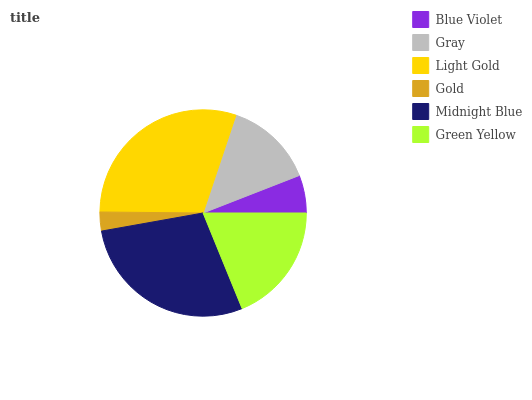Is Gold the minimum?
Answer yes or no. Yes. Is Light Gold the maximum?
Answer yes or no. Yes. Is Gray the minimum?
Answer yes or no. No. Is Gray the maximum?
Answer yes or no. No. Is Gray greater than Blue Violet?
Answer yes or no. Yes. Is Blue Violet less than Gray?
Answer yes or no. Yes. Is Blue Violet greater than Gray?
Answer yes or no. No. Is Gray less than Blue Violet?
Answer yes or no. No. Is Green Yellow the high median?
Answer yes or no. Yes. Is Gray the low median?
Answer yes or no. Yes. Is Gold the high median?
Answer yes or no. No. Is Green Yellow the low median?
Answer yes or no. No. 